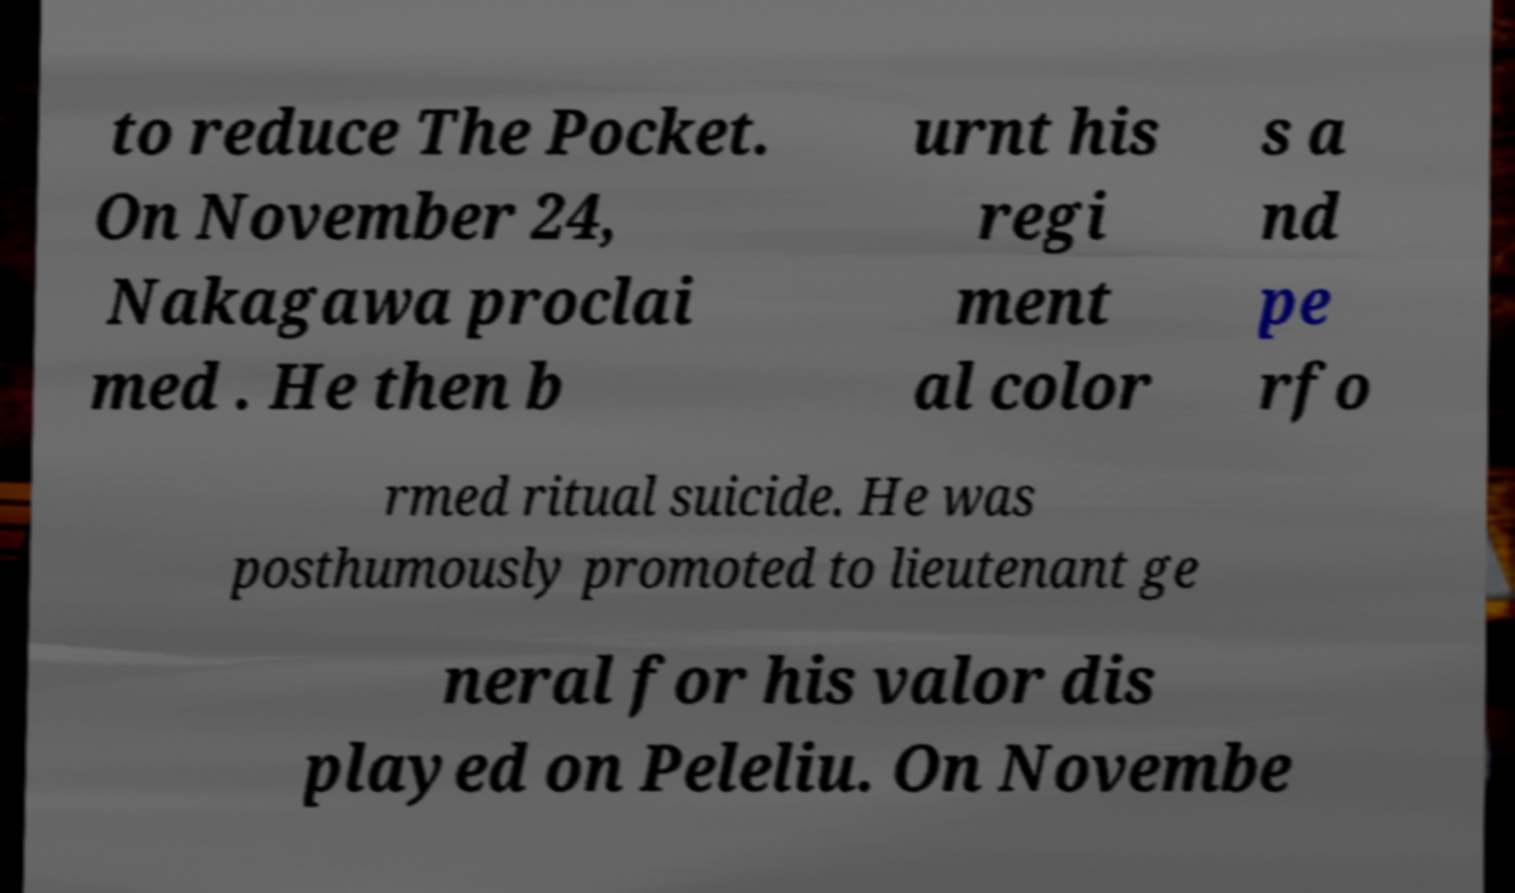Could you assist in decoding the text presented in this image and type it out clearly? to reduce The Pocket. On November 24, Nakagawa proclai med . He then b urnt his regi ment al color s a nd pe rfo rmed ritual suicide. He was posthumously promoted to lieutenant ge neral for his valor dis played on Peleliu. On Novembe 